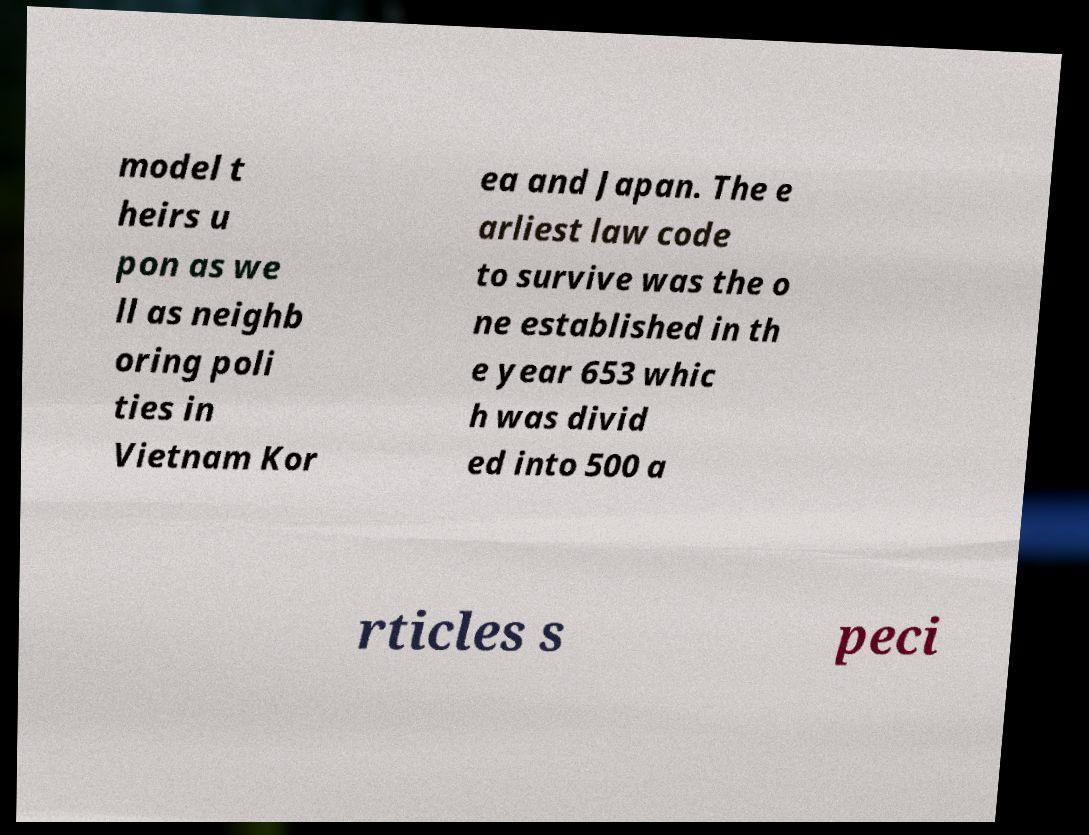What messages or text are displayed in this image? I need them in a readable, typed format. model t heirs u pon as we ll as neighb oring poli ties in Vietnam Kor ea and Japan. The e arliest law code to survive was the o ne established in th e year 653 whic h was divid ed into 500 a rticles s peci 